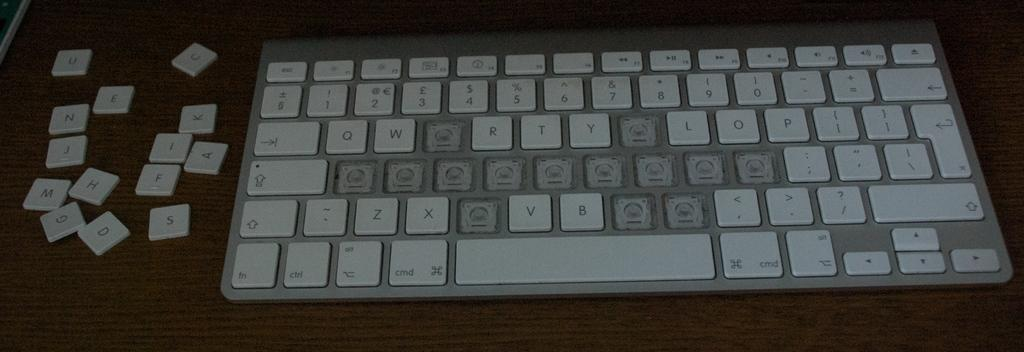What is the main object in the image? There is a keyboard in the image. What can be seen on the keyboard? The keys of the keyboard are visible. What type of surface is the keyboard placed on? The keyboard is on a wooden surface. What type of oatmeal is being prepared on the keyboard in the image? There is no oatmeal present in the image, and the keyboard is not being used for cooking or food preparation. 